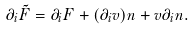<formula> <loc_0><loc_0><loc_500><loc_500>\partial _ { i } \tilde { F } = \partial _ { i } F + ( \partial _ { i } v ) n + v \partial _ { i } n .</formula> 